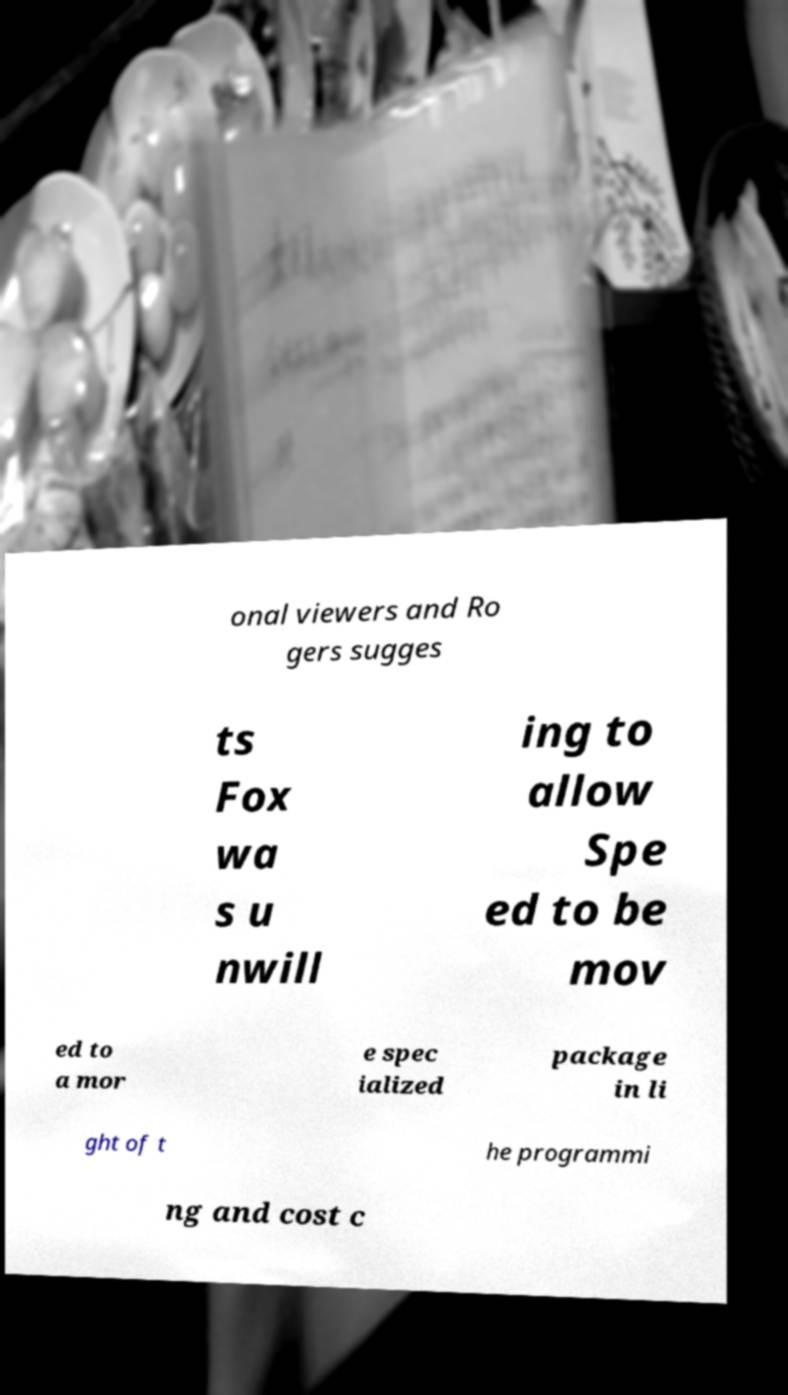Could you assist in decoding the text presented in this image and type it out clearly? onal viewers and Ro gers sugges ts Fox wa s u nwill ing to allow Spe ed to be mov ed to a mor e spec ialized package in li ght of t he programmi ng and cost c 